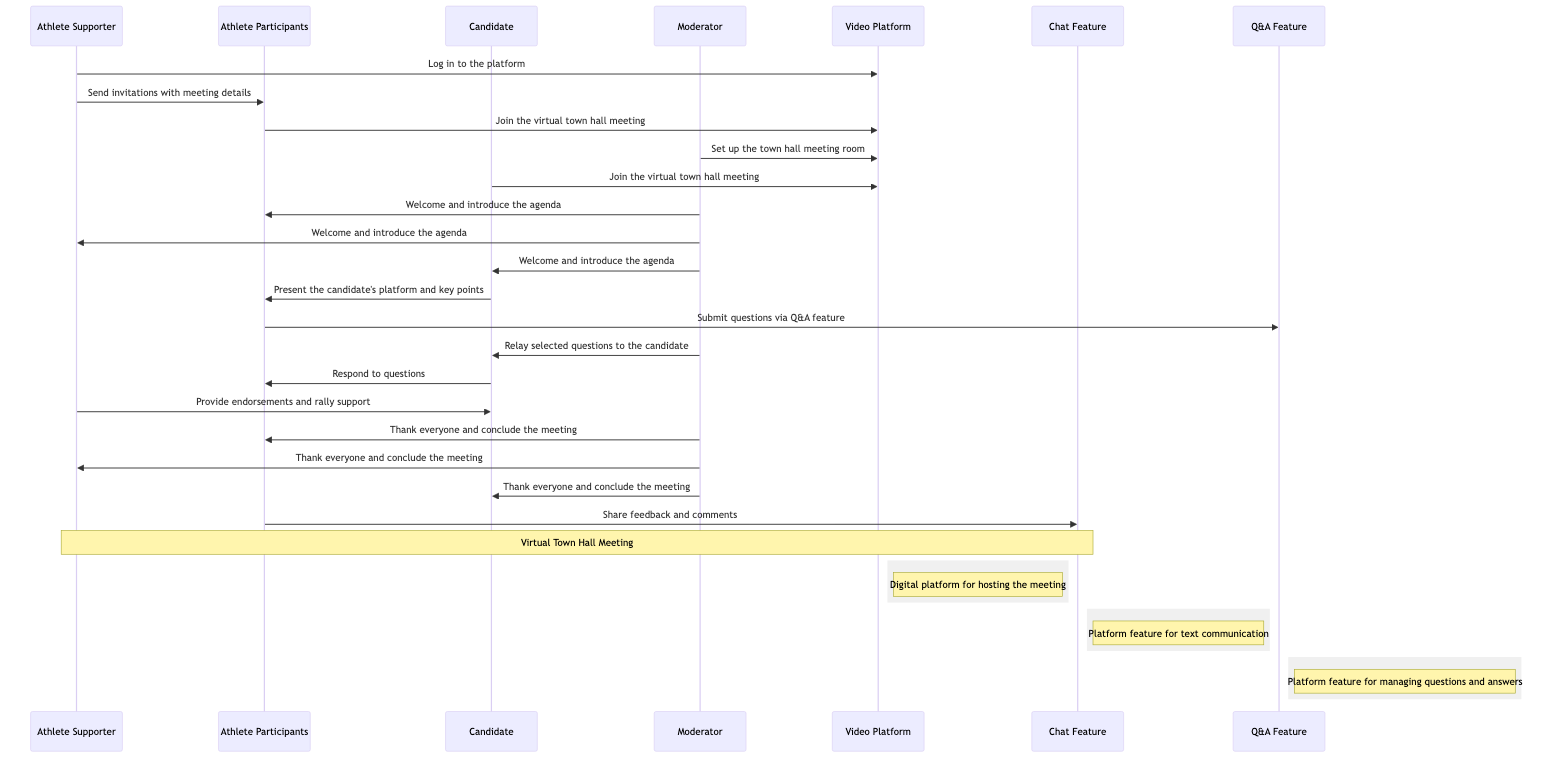What is the role of the Athlete Supporter? The diagram shows that the Athlete Supporter’s role is to support the candidate, send invitations, and provide endorsements.
Answer: star athlete who supports the candidate How many main actors are involved in the sequence diagram? The diagram lists four main actors: Athlete Supporter, Athlete Participants, Candidate, and Moderator.
Answer: 4 What message does the Moderator send after joining the Video Platform? According to the sequence of interactions, the Moderator sends a welcome message and introduces the agenda after joining.
Answer: Welcome and introduce the agenda Which feature do Athlete Participants use to submit questions? The diagram indicates that Athlete Participants use the Q&A feature to submit their questions during the town hall meeting.
Answer: Q&A Feature What action does the Candidate take in the process? The Candidate joins the virtual town hall meeting and presents their platform, additionally responding to questions from the Athlete Participants.
Answer: Join the virtual town hall meeting How is feedback shared by Athlete Participants? The diagram specifies that Athlete Participants share their feedback and comments through the Chat Feature.
Answer: Chat Feature What is the sequence of sending invitations? The Athlete Supporter sends invitations to the Athlete Participants after logging in to the Video Platform, as indicated in the flow of interactions.
Answer: Send invitations with meeting details What message does the Moderator send to the Candidate? Throughout the meeting, the Moderator relays selected questions from the Athlete Participants to the Candidate for answering.
Answer: Relay selected questions to the candidate What role does the Video Platform play in this diagram? The Video Platform serves as the digital location where the virtual town hall meeting takes place, facilitating all interactions.
Answer: Digital platform for hosting the meeting 